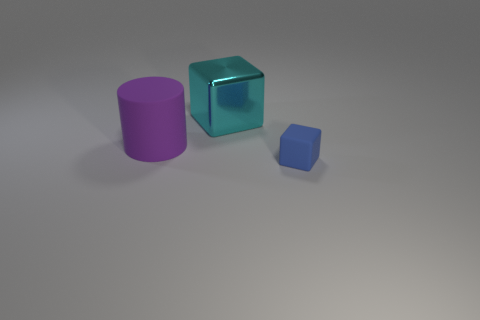Are the large cube and the blue cube made of the same material?
Make the answer very short. No. How many blocks are either tiny red objects or tiny objects?
Ensure brevity in your answer.  1. There is a block that is behind the cube in front of the cyan metallic object; what is its color?
Ensure brevity in your answer.  Cyan. How many big metal objects are behind the thing to the left of the block that is behind the big purple matte cylinder?
Keep it short and to the point. 1. There is a large thing that is right of the big matte cylinder; does it have the same shape as the rubber thing on the right side of the big cyan thing?
Offer a very short reply. Yes. What number of objects are either cyan metallic blocks or big blue matte spheres?
Keep it short and to the point. 1. What material is the thing to the left of the cube on the left side of the blue object?
Ensure brevity in your answer.  Rubber. Is there a metal object that has the same color as the cylinder?
Provide a succinct answer. No. There is a block that is the same size as the purple thing; what is its color?
Provide a short and direct response. Cyan. There is a cube that is on the left side of the thing in front of the big thing that is in front of the cyan metallic object; what is its material?
Provide a succinct answer. Metal. 